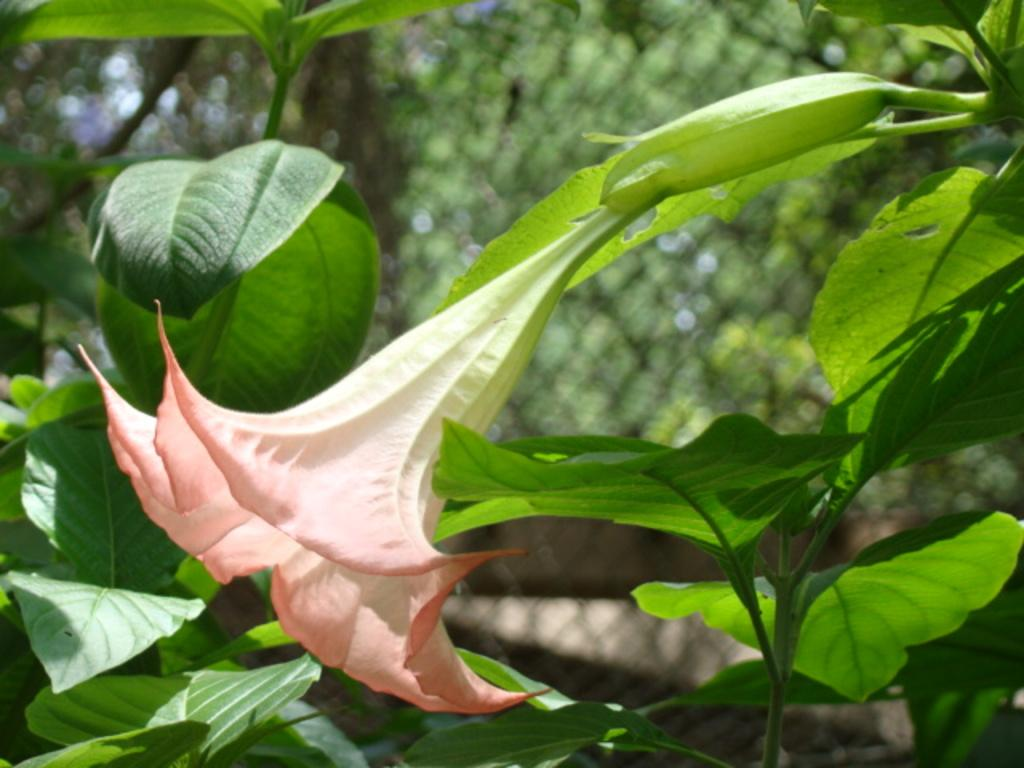What type of plant is the main subject of the image? There is a flower in the image. What other types of plants can be seen in the image? There are plants in the image. What can be seen in the background of the image? There are trees and a fence in the background of the image. What type of song is being played in the background of the image? There is no song or audio present in the image; it is a still image of a flower, plants, trees, and a fence. 